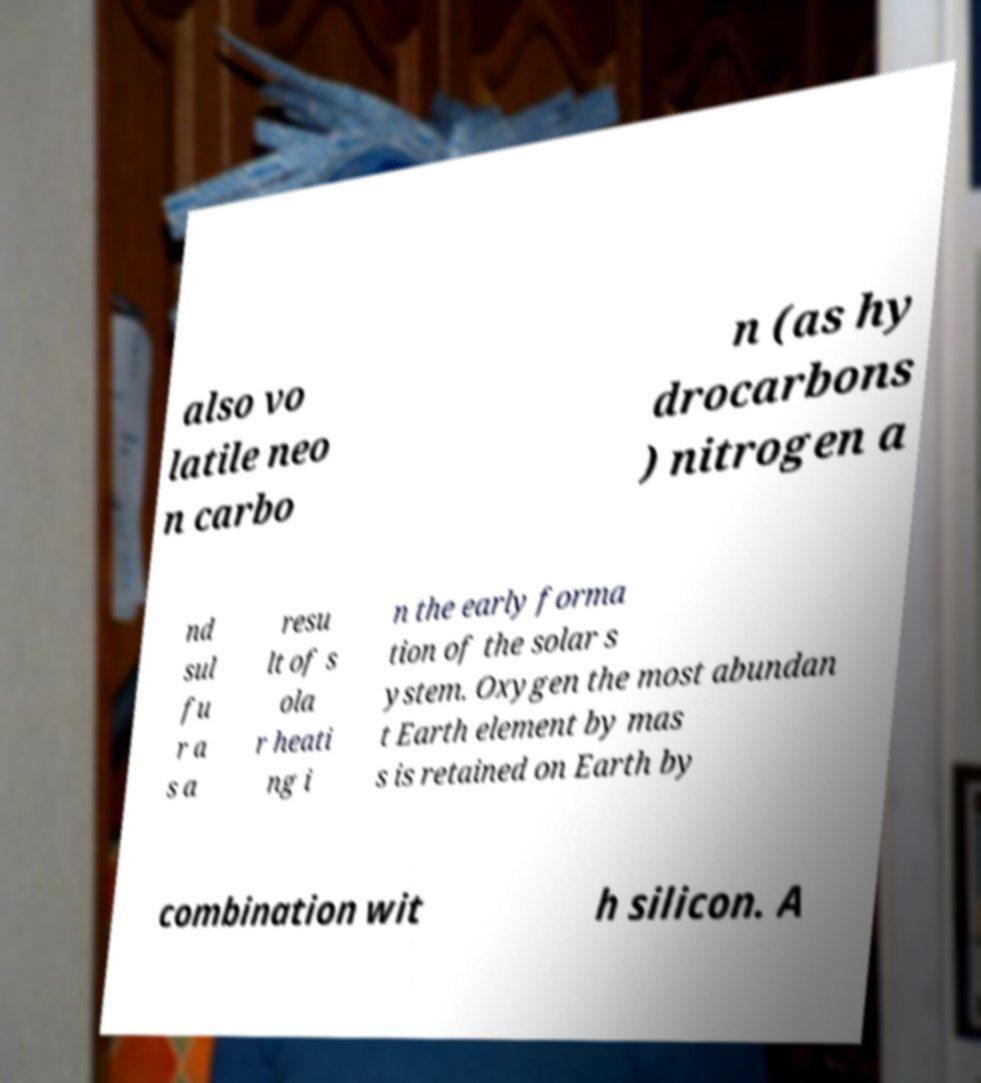Please read and relay the text visible in this image. What does it say? also vo latile neo n carbo n (as hy drocarbons ) nitrogen a nd sul fu r a s a resu lt of s ola r heati ng i n the early forma tion of the solar s ystem. Oxygen the most abundan t Earth element by mas s is retained on Earth by combination wit h silicon. A 